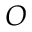<formula> <loc_0><loc_0><loc_500><loc_500>O</formula> 